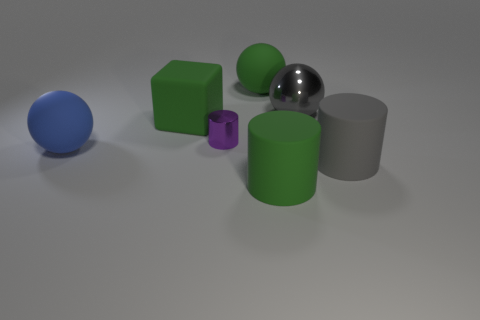Subtract 1 balls. How many balls are left? 2 Subtract all big matte cylinders. How many cylinders are left? 1 Add 1 purple things. How many objects exist? 8 Subtract all cubes. How many objects are left? 6 Subtract all tiny gray rubber things. Subtract all large matte cubes. How many objects are left? 6 Add 5 green cylinders. How many green cylinders are left? 6 Add 1 big green metallic balls. How many big green metallic balls exist? 1 Subtract 0 yellow blocks. How many objects are left? 7 